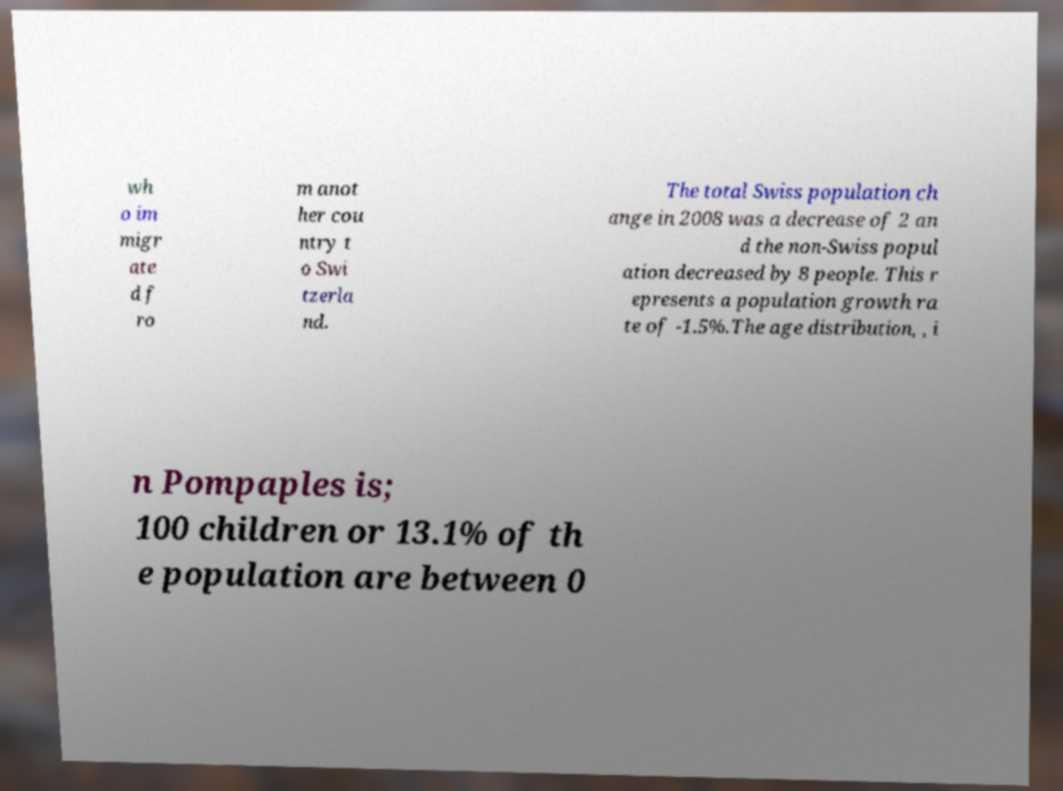Please read and relay the text visible in this image. What does it say? wh o im migr ate d f ro m anot her cou ntry t o Swi tzerla nd. The total Swiss population ch ange in 2008 was a decrease of 2 an d the non-Swiss popul ation decreased by 8 people. This r epresents a population growth ra te of -1.5%.The age distribution, , i n Pompaples is; 100 children or 13.1% of th e population are between 0 